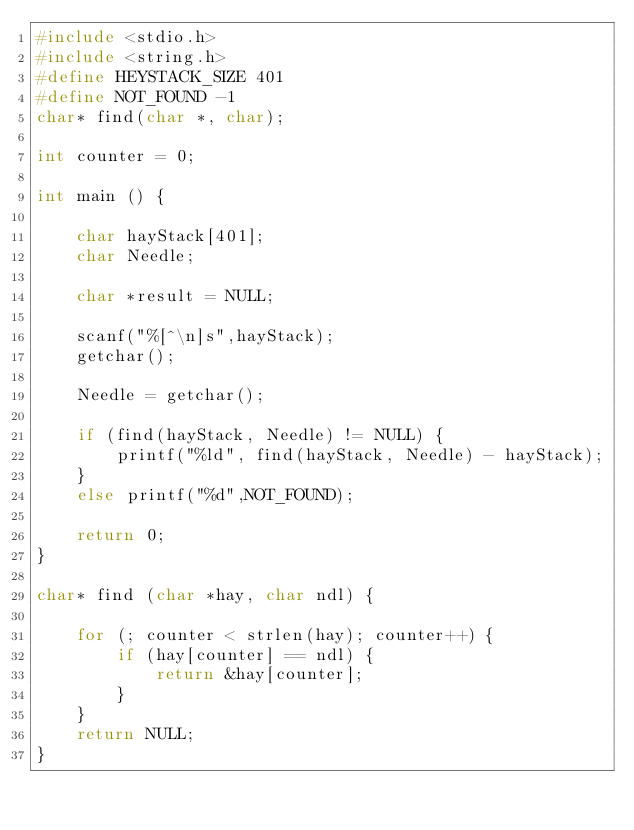<code> <loc_0><loc_0><loc_500><loc_500><_C_>#include <stdio.h>
#include <string.h>
#define HEYSTACK_SIZE 401
#define NOT_FOUND -1
char* find(char *, char);

int counter = 0;

int main () {

	char hayStack[401];
	char Needle;

	char *result = NULL;

	scanf("%[^\n]s",hayStack);
	getchar();
	
	Needle = getchar();

	if (find(hayStack, Needle) != NULL) {
		printf("%ld", find(hayStack, Needle) - hayStack);
	}
	else printf("%d",NOT_FOUND);

	return 0;
}

char* find (char *hay, char ndl) {

	for (; counter < strlen(hay); counter++) {
		if (hay[counter] == ndl) {
			return &hay[counter];
		}
	}
	return NULL;
}
</code> 